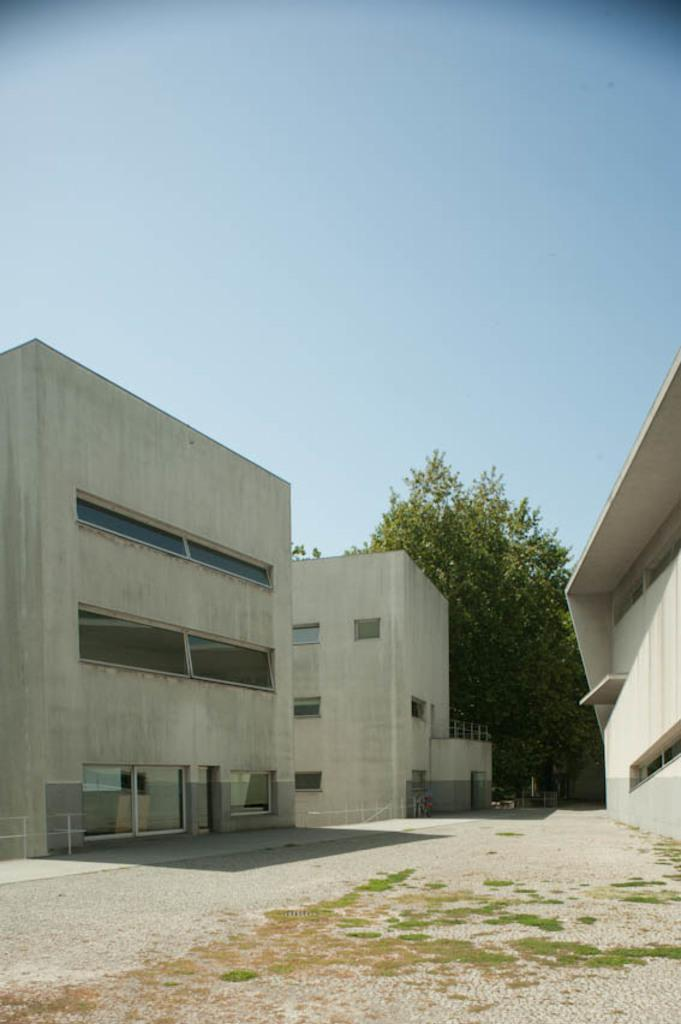What structures are visible in the image? There are buildings in the image. What type of vegetation is present in the image? There are trees in the image. What part of the natural environment is visible in the image? The sky is visible in the background of the image. Where is the mom in the image? There is no mom present in the image. What type of nerve is visible in the image? There is no nerve present in the image. 